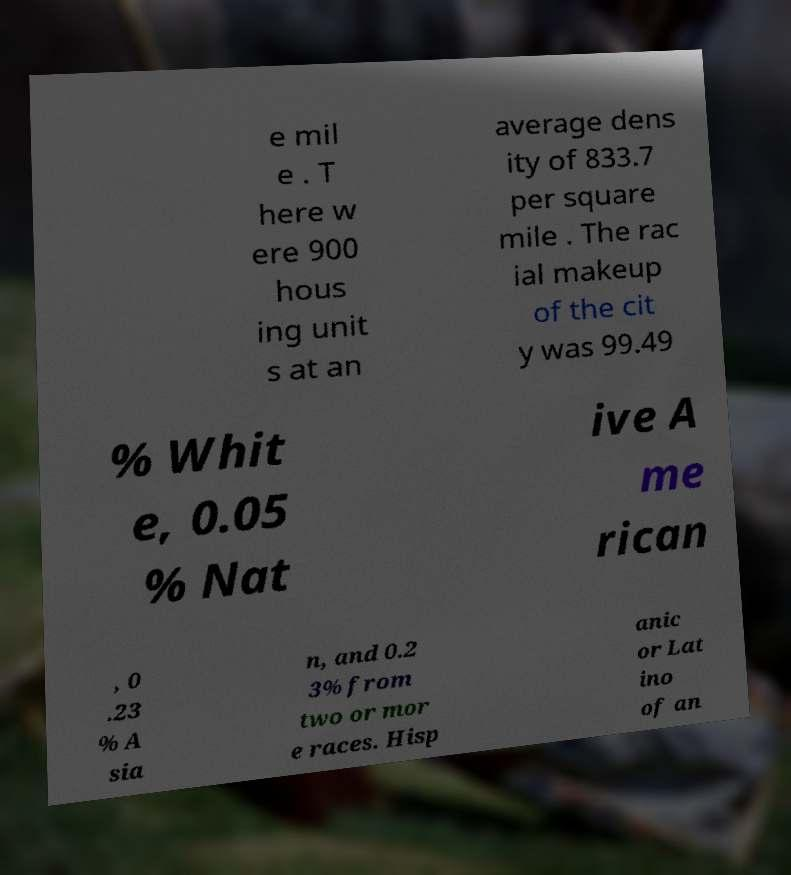What messages or text are displayed in this image? I need them in a readable, typed format. e mil e . T here w ere 900 hous ing unit s at an average dens ity of 833.7 per square mile . The rac ial makeup of the cit y was 99.49 % Whit e, 0.05 % Nat ive A me rican , 0 .23 % A sia n, and 0.2 3% from two or mor e races. Hisp anic or Lat ino of an 